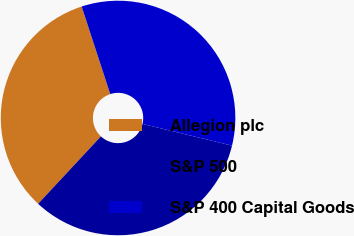Convert chart. <chart><loc_0><loc_0><loc_500><loc_500><pie_chart><fcel>Allegion plc<fcel>S&P 500<fcel>S&P 400 Capital Goods<nl><fcel>33.04%<fcel>33.15%<fcel>33.81%<nl></chart> 